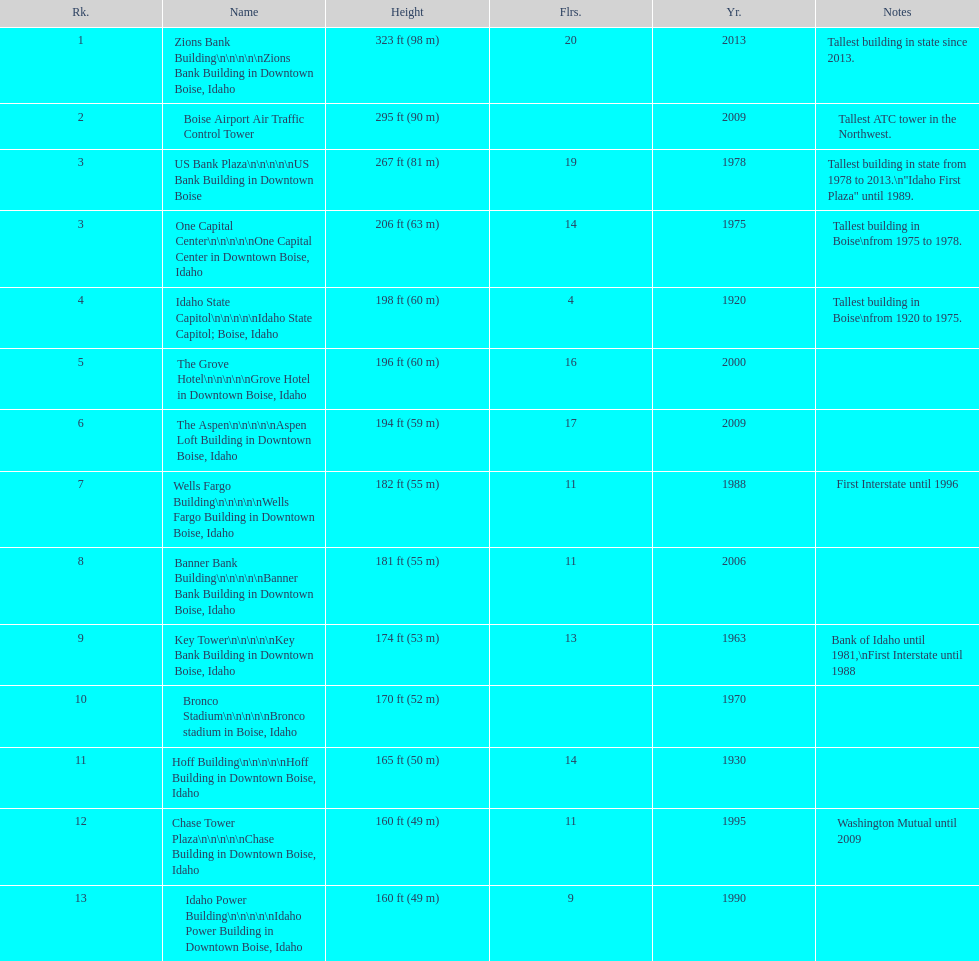What is the number of floors of the oldest building? 4. 